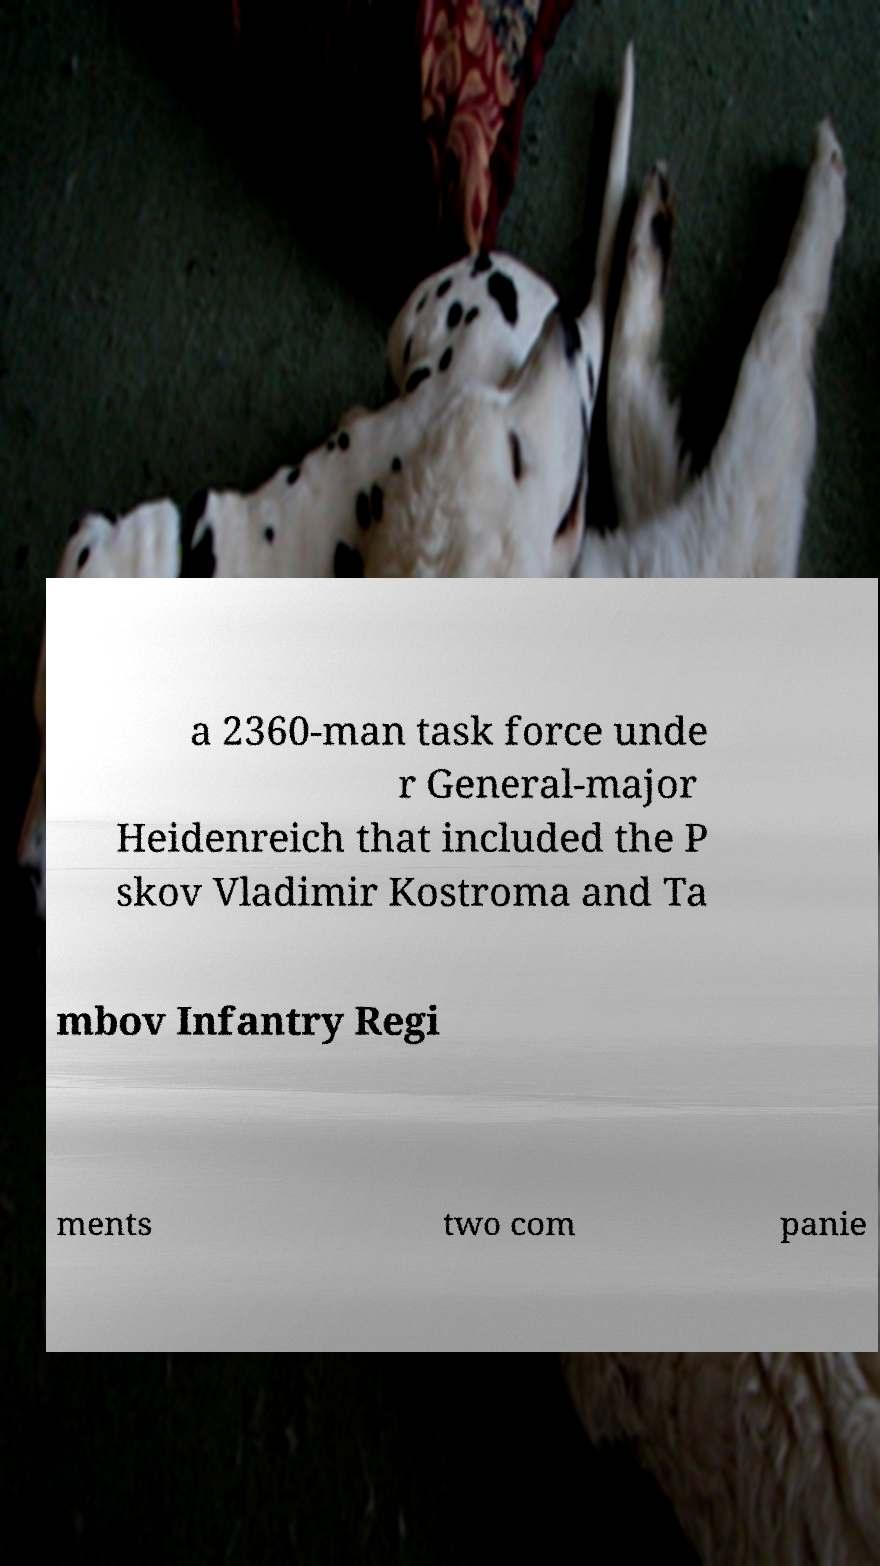I need the written content from this picture converted into text. Can you do that? a 2360-man task force unde r General-major Heidenreich that included the P skov Vladimir Kostroma and Ta mbov Infantry Regi ments two com panie 